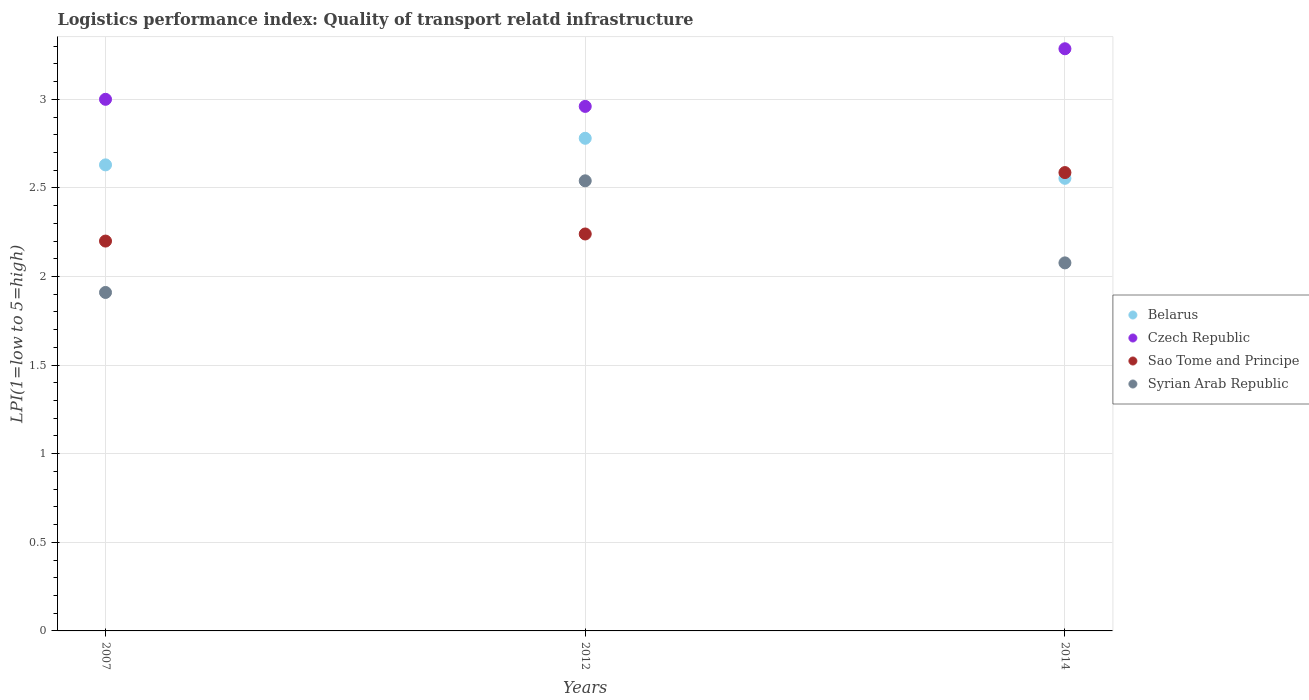Is the number of dotlines equal to the number of legend labels?
Provide a succinct answer. Yes. Across all years, what is the maximum logistics performance index in Czech Republic?
Give a very brief answer. 3.29. Across all years, what is the minimum logistics performance index in Belarus?
Provide a succinct answer. 2.55. In which year was the logistics performance index in Sao Tome and Principe maximum?
Provide a short and direct response. 2014. What is the total logistics performance index in Sao Tome and Principe in the graph?
Provide a short and direct response. 7.03. What is the difference between the logistics performance index in Sao Tome and Principe in 2012 and that in 2014?
Offer a terse response. -0.35. What is the difference between the logistics performance index in Belarus in 2012 and the logistics performance index in Syrian Arab Republic in 2007?
Your response must be concise. 0.87. What is the average logistics performance index in Belarus per year?
Your response must be concise. 2.65. In the year 2014, what is the difference between the logistics performance index in Belarus and logistics performance index in Syrian Arab Republic?
Ensure brevity in your answer.  0.48. What is the ratio of the logistics performance index in Sao Tome and Principe in 2007 to that in 2014?
Give a very brief answer. 0.85. Is the logistics performance index in Czech Republic in 2007 less than that in 2012?
Provide a short and direct response. No. Is the difference between the logistics performance index in Belarus in 2007 and 2014 greater than the difference between the logistics performance index in Syrian Arab Republic in 2007 and 2014?
Make the answer very short. Yes. What is the difference between the highest and the second highest logistics performance index in Belarus?
Offer a very short reply. 0.15. What is the difference between the highest and the lowest logistics performance index in Sao Tome and Principe?
Keep it short and to the point. 0.39. Is it the case that in every year, the sum of the logistics performance index in Belarus and logistics performance index in Sao Tome and Principe  is greater than the sum of logistics performance index in Czech Republic and logistics performance index in Syrian Arab Republic?
Give a very brief answer. Yes. Is it the case that in every year, the sum of the logistics performance index in Belarus and logistics performance index in Czech Republic  is greater than the logistics performance index in Sao Tome and Principe?
Ensure brevity in your answer.  Yes. Does the logistics performance index in Sao Tome and Principe monotonically increase over the years?
Make the answer very short. Yes. Is the logistics performance index in Syrian Arab Republic strictly greater than the logistics performance index in Belarus over the years?
Give a very brief answer. No. How many dotlines are there?
Your answer should be compact. 4. How many years are there in the graph?
Give a very brief answer. 3. What is the difference between two consecutive major ticks on the Y-axis?
Provide a short and direct response. 0.5. How are the legend labels stacked?
Your answer should be very brief. Vertical. What is the title of the graph?
Provide a short and direct response. Logistics performance index: Quality of transport relatd infrastructure. Does "Turkey" appear as one of the legend labels in the graph?
Provide a short and direct response. No. What is the label or title of the X-axis?
Your response must be concise. Years. What is the label or title of the Y-axis?
Offer a terse response. LPI(1=low to 5=high). What is the LPI(1=low to 5=high) of Belarus in 2007?
Give a very brief answer. 2.63. What is the LPI(1=low to 5=high) in Czech Republic in 2007?
Your answer should be compact. 3. What is the LPI(1=low to 5=high) in Syrian Arab Republic in 2007?
Offer a very short reply. 1.91. What is the LPI(1=low to 5=high) of Belarus in 2012?
Make the answer very short. 2.78. What is the LPI(1=low to 5=high) in Czech Republic in 2012?
Give a very brief answer. 2.96. What is the LPI(1=low to 5=high) of Sao Tome and Principe in 2012?
Provide a succinct answer. 2.24. What is the LPI(1=low to 5=high) of Syrian Arab Republic in 2012?
Offer a very short reply. 2.54. What is the LPI(1=low to 5=high) in Belarus in 2014?
Your answer should be very brief. 2.55. What is the LPI(1=low to 5=high) in Czech Republic in 2014?
Keep it short and to the point. 3.29. What is the LPI(1=low to 5=high) of Sao Tome and Principe in 2014?
Offer a terse response. 2.59. What is the LPI(1=low to 5=high) in Syrian Arab Republic in 2014?
Provide a succinct answer. 2.08. Across all years, what is the maximum LPI(1=low to 5=high) of Belarus?
Provide a succinct answer. 2.78. Across all years, what is the maximum LPI(1=low to 5=high) in Czech Republic?
Ensure brevity in your answer.  3.29. Across all years, what is the maximum LPI(1=low to 5=high) of Sao Tome and Principe?
Provide a succinct answer. 2.59. Across all years, what is the maximum LPI(1=low to 5=high) in Syrian Arab Republic?
Provide a short and direct response. 2.54. Across all years, what is the minimum LPI(1=low to 5=high) in Belarus?
Your answer should be compact. 2.55. Across all years, what is the minimum LPI(1=low to 5=high) in Czech Republic?
Offer a terse response. 2.96. Across all years, what is the minimum LPI(1=low to 5=high) in Sao Tome and Principe?
Offer a terse response. 2.2. Across all years, what is the minimum LPI(1=low to 5=high) in Syrian Arab Republic?
Your answer should be compact. 1.91. What is the total LPI(1=low to 5=high) of Belarus in the graph?
Offer a terse response. 7.96. What is the total LPI(1=low to 5=high) in Czech Republic in the graph?
Your answer should be compact. 9.25. What is the total LPI(1=low to 5=high) in Sao Tome and Principe in the graph?
Make the answer very short. 7.03. What is the total LPI(1=low to 5=high) of Syrian Arab Republic in the graph?
Give a very brief answer. 6.53. What is the difference between the LPI(1=low to 5=high) in Czech Republic in 2007 and that in 2012?
Offer a very short reply. 0.04. What is the difference between the LPI(1=low to 5=high) in Sao Tome and Principe in 2007 and that in 2012?
Your answer should be very brief. -0.04. What is the difference between the LPI(1=low to 5=high) of Syrian Arab Republic in 2007 and that in 2012?
Ensure brevity in your answer.  -0.63. What is the difference between the LPI(1=low to 5=high) of Belarus in 2007 and that in 2014?
Your response must be concise. 0.08. What is the difference between the LPI(1=low to 5=high) in Czech Republic in 2007 and that in 2014?
Offer a terse response. -0.29. What is the difference between the LPI(1=low to 5=high) of Sao Tome and Principe in 2007 and that in 2014?
Ensure brevity in your answer.  -0.39. What is the difference between the LPI(1=low to 5=high) in Syrian Arab Republic in 2007 and that in 2014?
Keep it short and to the point. -0.17. What is the difference between the LPI(1=low to 5=high) in Belarus in 2012 and that in 2014?
Give a very brief answer. 0.23. What is the difference between the LPI(1=low to 5=high) of Czech Republic in 2012 and that in 2014?
Offer a very short reply. -0.33. What is the difference between the LPI(1=low to 5=high) in Sao Tome and Principe in 2012 and that in 2014?
Provide a succinct answer. -0.35. What is the difference between the LPI(1=low to 5=high) in Syrian Arab Republic in 2012 and that in 2014?
Your response must be concise. 0.46. What is the difference between the LPI(1=low to 5=high) in Belarus in 2007 and the LPI(1=low to 5=high) in Czech Republic in 2012?
Ensure brevity in your answer.  -0.33. What is the difference between the LPI(1=low to 5=high) of Belarus in 2007 and the LPI(1=low to 5=high) of Sao Tome and Principe in 2012?
Your answer should be compact. 0.39. What is the difference between the LPI(1=low to 5=high) of Belarus in 2007 and the LPI(1=low to 5=high) of Syrian Arab Republic in 2012?
Your response must be concise. 0.09. What is the difference between the LPI(1=low to 5=high) in Czech Republic in 2007 and the LPI(1=low to 5=high) in Sao Tome and Principe in 2012?
Offer a terse response. 0.76. What is the difference between the LPI(1=low to 5=high) of Czech Republic in 2007 and the LPI(1=low to 5=high) of Syrian Arab Republic in 2012?
Your response must be concise. 0.46. What is the difference between the LPI(1=low to 5=high) in Sao Tome and Principe in 2007 and the LPI(1=low to 5=high) in Syrian Arab Republic in 2012?
Offer a terse response. -0.34. What is the difference between the LPI(1=low to 5=high) in Belarus in 2007 and the LPI(1=low to 5=high) in Czech Republic in 2014?
Provide a short and direct response. -0.66. What is the difference between the LPI(1=low to 5=high) of Belarus in 2007 and the LPI(1=low to 5=high) of Sao Tome and Principe in 2014?
Offer a very short reply. 0.04. What is the difference between the LPI(1=low to 5=high) of Belarus in 2007 and the LPI(1=low to 5=high) of Syrian Arab Republic in 2014?
Your response must be concise. 0.55. What is the difference between the LPI(1=low to 5=high) of Czech Republic in 2007 and the LPI(1=low to 5=high) of Sao Tome and Principe in 2014?
Your response must be concise. 0.41. What is the difference between the LPI(1=low to 5=high) in Czech Republic in 2007 and the LPI(1=low to 5=high) in Syrian Arab Republic in 2014?
Your response must be concise. 0.92. What is the difference between the LPI(1=low to 5=high) in Sao Tome and Principe in 2007 and the LPI(1=low to 5=high) in Syrian Arab Republic in 2014?
Offer a terse response. 0.12. What is the difference between the LPI(1=low to 5=high) of Belarus in 2012 and the LPI(1=low to 5=high) of Czech Republic in 2014?
Offer a terse response. -0.51. What is the difference between the LPI(1=low to 5=high) of Belarus in 2012 and the LPI(1=low to 5=high) of Sao Tome and Principe in 2014?
Your answer should be compact. 0.19. What is the difference between the LPI(1=low to 5=high) of Belarus in 2012 and the LPI(1=low to 5=high) of Syrian Arab Republic in 2014?
Your response must be concise. 0.7. What is the difference between the LPI(1=low to 5=high) of Czech Republic in 2012 and the LPI(1=low to 5=high) of Sao Tome and Principe in 2014?
Provide a succinct answer. 0.37. What is the difference between the LPI(1=low to 5=high) of Czech Republic in 2012 and the LPI(1=low to 5=high) of Syrian Arab Republic in 2014?
Keep it short and to the point. 0.88. What is the difference between the LPI(1=low to 5=high) in Sao Tome and Principe in 2012 and the LPI(1=low to 5=high) in Syrian Arab Republic in 2014?
Keep it short and to the point. 0.16. What is the average LPI(1=low to 5=high) in Belarus per year?
Your answer should be very brief. 2.65. What is the average LPI(1=low to 5=high) in Czech Republic per year?
Your answer should be compact. 3.08. What is the average LPI(1=low to 5=high) in Sao Tome and Principe per year?
Give a very brief answer. 2.34. What is the average LPI(1=low to 5=high) in Syrian Arab Republic per year?
Keep it short and to the point. 2.18. In the year 2007, what is the difference between the LPI(1=low to 5=high) in Belarus and LPI(1=low to 5=high) in Czech Republic?
Your response must be concise. -0.37. In the year 2007, what is the difference between the LPI(1=low to 5=high) in Belarus and LPI(1=low to 5=high) in Sao Tome and Principe?
Ensure brevity in your answer.  0.43. In the year 2007, what is the difference between the LPI(1=low to 5=high) in Belarus and LPI(1=low to 5=high) in Syrian Arab Republic?
Give a very brief answer. 0.72. In the year 2007, what is the difference between the LPI(1=low to 5=high) of Czech Republic and LPI(1=low to 5=high) of Sao Tome and Principe?
Provide a succinct answer. 0.8. In the year 2007, what is the difference between the LPI(1=low to 5=high) of Czech Republic and LPI(1=low to 5=high) of Syrian Arab Republic?
Give a very brief answer. 1.09. In the year 2007, what is the difference between the LPI(1=low to 5=high) in Sao Tome and Principe and LPI(1=low to 5=high) in Syrian Arab Republic?
Your response must be concise. 0.29. In the year 2012, what is the difference between the LPI(1=low to 5=high) in Belarus and LPI(1=low to 5=high) in Czech Republic?
Keep it short and to the point. -0.18. In the year 2012, what is the difference between the LPI(1=low to 5=high) in Belarus and LPI(1=low to 5=high) in Sao Tome and Principe?
Your response must be concise. 0.54. In the year 2012, what is the difference between the LPI(1=low to 5=high) of Belarus and LPI(1=low to 5=high) of Syrian Arab Republic?
Your answer should be compact. 0.24. In the year 2012, what is the difference between the LPI(1=low to 5=high) of Czech Republic and LPI(1=low to 5=high) of Sao Tome and Principe?
Offer a very short reply. 0.72. In the year 2012, what is the difference between the LPI(1=low to 5=high) in Czech Republic and LPI(1=low to 5=high) in Syrian Arab Republic?
Provide a succinct answer. 0.42. In the year 2014, what is the difference between the LPI(1=low to 5=high) in Belarus and LPI(1=low to 5=high) in Czech Republic?
Offer a very short reply. -0.73. In the year 2014, what is the difference between the LPI(1=low to 5=high) of Belarus and LPI(1=low to 5=high) of Sao Tome and Principe?
Your answer should be very brief. -0.03. In the year 2014, what is the difference between the LPI(1=low to 5=high) in Belarus and LPI(1=low to 5=high) in Syrian Arab Republic?
Make the answer very short. 0.48. In the year 2014, what is the difference between the LPI(1=low to 5=high) in Czech Republic and LPI(1=low to 5=high) in Sao Tome and Principe?
Make the answer very short. 0.7. In the year 2014, what is the difference between the LPI(1=low to 5=high) of Czech Republic and LPI(1=low to 5=high) of Syrian Arab Republic?
Offer a terse response. 1.21. In the year 2014, what is the difference between the LPI(1=low to 5=high) in Sao Tome and Principe and LPI(1=low to 5=high) in Syrian Arab Republic?
Your answer should be very brief. 0.51. What is the ratio of the LPI(1=low to 5=high) in Belarus in 2007 to that in 2012?
Your response must be concise. 0.95. What is the ratio of the LPI(1=low to 5=high) of Czech Republic in 2007 to that in 2012?
Your answer should be compact. 1.01. What is the ratio of the LPI(1=low to 5=high) of Sao Tome and Principe in 2007 to that in 2012?
Offer a terse response. 0.98. What is the ratio of the LPI(1=low to 5=high) of Syrian Arab Republic in 2007 to that in 2012?
Offer a terse response. 0.75. What is the ratio of the LPI(1=low to 5=high) in Belarus in 2007 to that in 2014?
Offer a very short reply. 1.03. What is the ratio of the LPI(1=low to 5=high) in Czech Republic in 2007 to that in 2014?
Make the answer very short. 0.91. What is the ratio of the LPI(1=low to 5=high) in Sao Tome and Principe in 2007 to that in 2014?
Your response must be concise. 0.85. What is the ratio of the LPI(1=low to 5=high) of Syrian Arab Republic in 2007 to that in 2014?
Give a very brief answer. 0.92. What is the ratio of the LPI(1=low to 5=high) of Belarus in 2012 to that in 2014?
Make the answer very short. 1.09. What is the ratio of the LPI(1=low to 5=high) of Czech Republic in 2012 to that in 2014?
Your answer should be compact. 0.9. What is the ratio of the LPI(1=low to 5=high) in Sao Tome and Principe in 2012 to that in 2014?
Your response must be concise. 0.87. What is the ratio of the LPI(1=low to 5=high) in Syrian Arab Republic in 2012 to that in 2014?
Offer a very short reply. 1.22. What is the difference between the highest and the second highest LPI(1=low to 5=high) of Belarus?
Give a very brief answer. 0.15. What is the difference between the highest and the second highest LPI(1=low to 5=high) in Czech Republic?
Your answer should be very brief. 0.29. What is the difference between the highest and the second highest LPI(1=low to 5=high) in Sao Tome and Principe?
Your answer should be very brief. 0.35. What is the difference between the highest and the second highest LPI(1=low to 5=high) in Syrian Arab Republic?
Provide a succinct answer. 0.46. What is the difference between the highest and the lowest LPI(1=low to 5=high) of Belarus?
Your answer should be compact. 0.23. What is the difference between the highest and the lowest LPI(1=low to 5=high) in Czech Republic?
Give a very brief answer. 0.33. What is the difference between the highest and the lowest LPI(1=low to 5=high) in Sao Tome and Principe?
Make the answer very short. 0.39. What is the difference between the highest and the lowest LPI(1=low to 5=high) in Syrian Arab Republic?
Give a very brief answer. 0.63. 